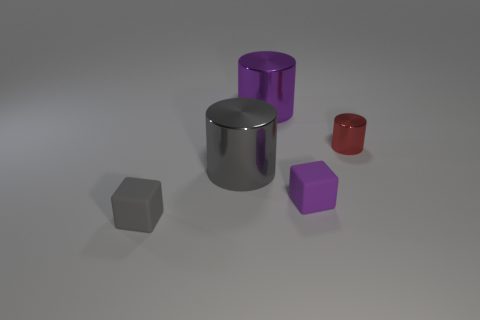Is there a red thing that has the same shape as the gray shiny object?
Offer a very short reply. Yes. There is a tiny block that is to the left of the cylinder to the left of the large shiny cylinder behind the red shiny thing; what is it made of?
Provide a succinct answer. Rubber. How many other things are there of the same size as the gray cylinder?
Provide a short and direct response. 1. The small metal object has what color?
Your answer should be compact. Red. What number of metal things are blocks or small purple blocks?
Your answer should be very brief. 0. Is there anything else that is the same material as the small gray thing?
Provide a short and direct response. Yes. There is a purple object to the left of the rubber object that is behind the rubber thing left of the big purple shiny cylinder; how big is it?
Offer a terse response. Large. What size is the thing that is both left of the purple metallic cylinder and behind the small gray object?
Your answer should be compact. Large. Does the small matte block that is behind the gray matte cube have the same color as the large metallic thing behind the small cylinder?
Give a very brief answer. Yes. What number of small purple rubber things are in front of the purple matte object?
Make the answer very short. 0. 